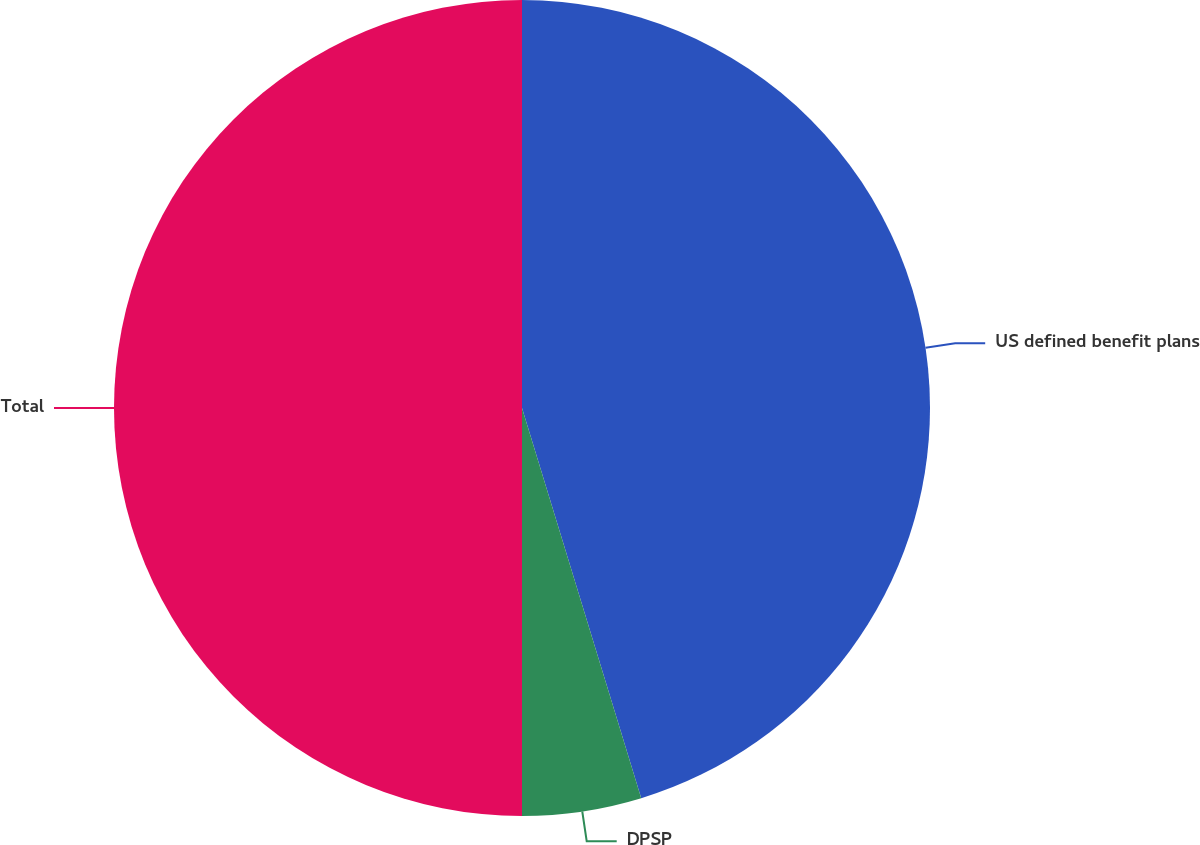Convert chart. <chart><loc_0><loc_0><loc_500><loc_500><pie_chart><fcel>US defined benefit plans<fcel>DPSP<fcel>Total<nl><fcel>45.28%<fcel>4.72%<fcel>50.0%<nl></chart> 